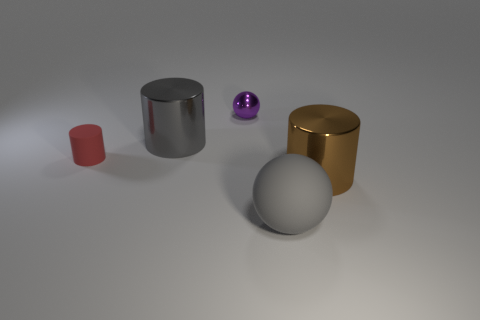Subtract all large brown cylinders. How many cylinders are left? 2 Add 2 tiny brown shiny things. How many objects exist? 7 Subtract all red cylinders. How many cylinders are left? 2 Subtract all cylinders. How many objects are left? 2 Subtract all blue balls. Subtract all blue cylinders. How many balls are left? 2 Subtract all large green rubber cylinders. Subtract all gray things. How many objects are left? 3 Add 4 big spheres. How many big spheres are left? 5 Add 4 tiny purple shiny spheres. How many tiny purple shiny spheres exist? 5 Subtract 1 gray cylinders. How many objects are left? 4 Subtract 1 balls. How many balls are left? 1 